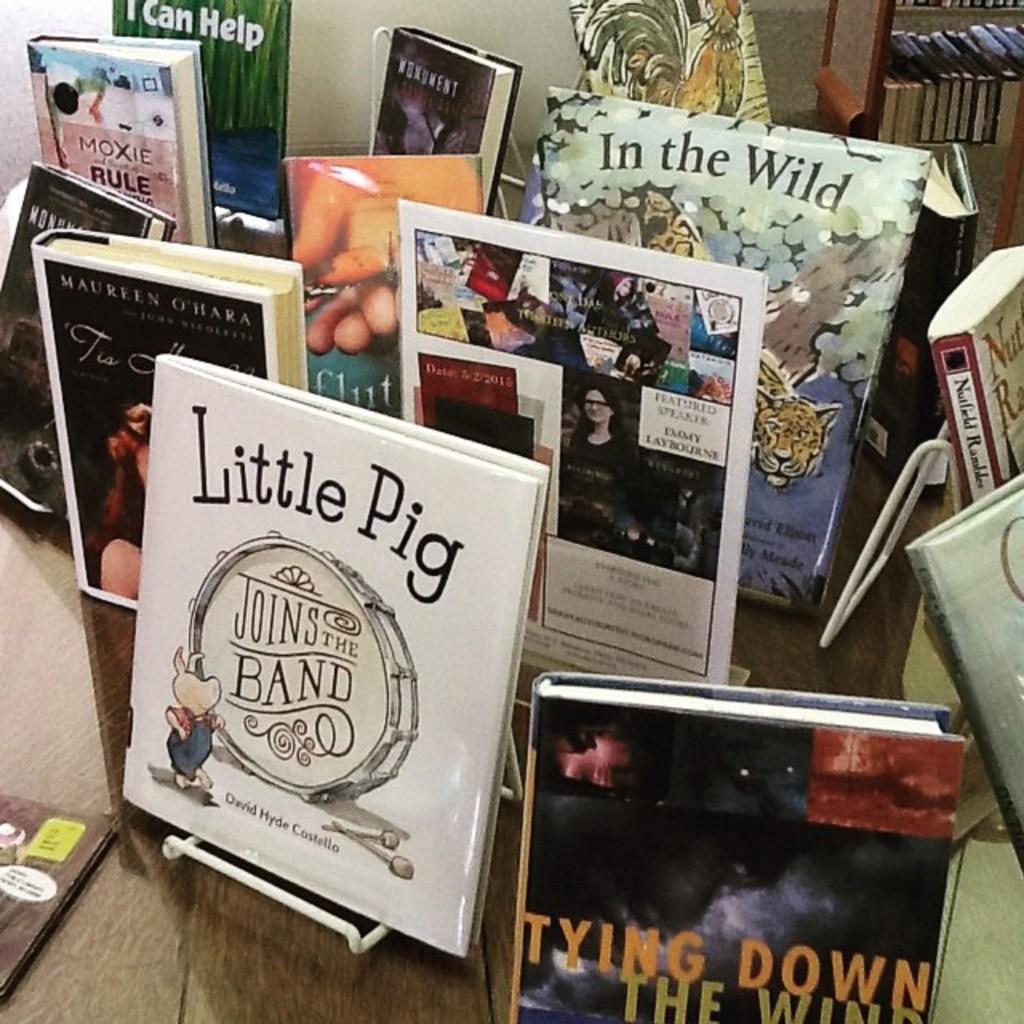Who wrote little pig joins the band?
Your answer should be compact. David hyde costello. 